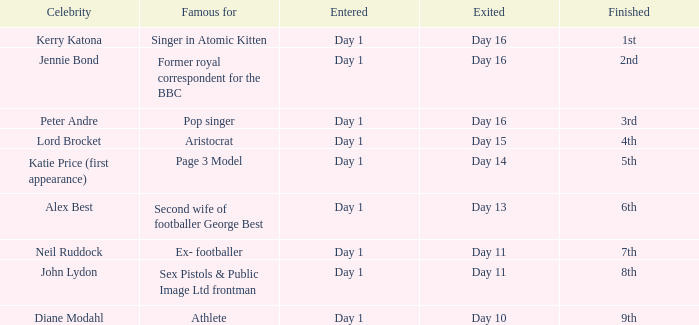Name the finished for exited day 13 6th. 